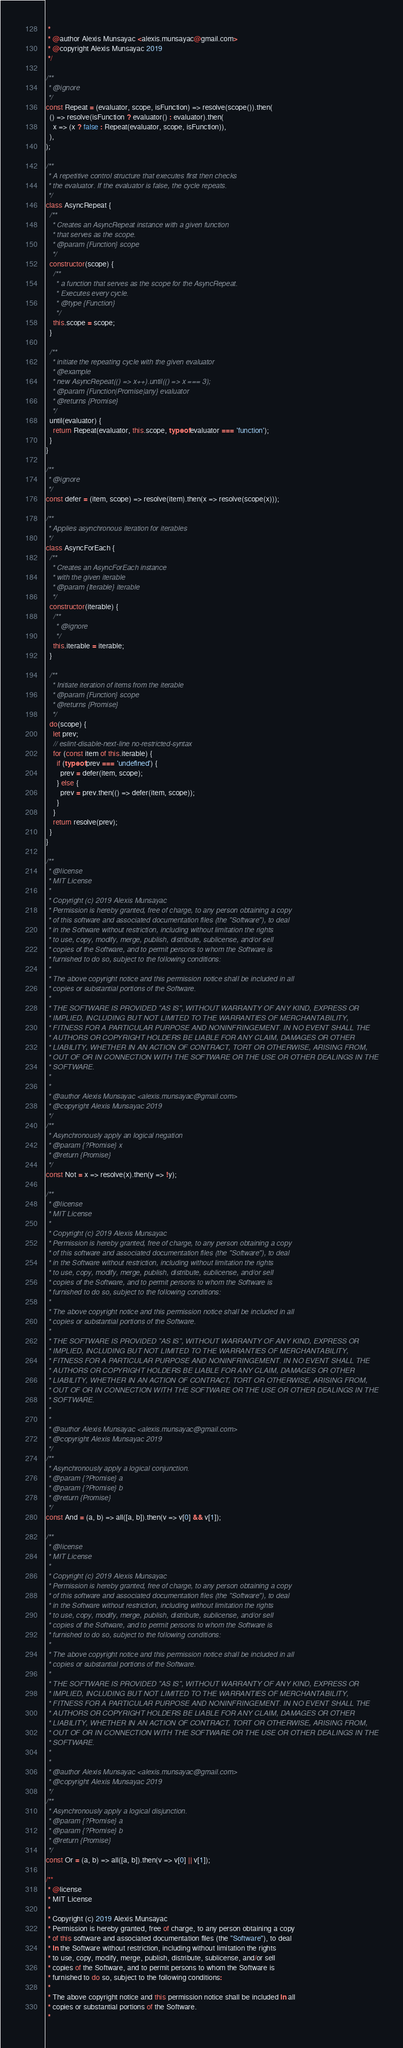<code> <loc_0><loc_0><loc_500><loc_500><_JavaScript_> *
 * @author Alexis Munsayac <alexis.munsayac@gmail.com>
 * @copyright Alexis Munsayac 2019
 */

/**
 * @ignore
 */
const Repeat = (evaluator, scope, isFunction) => resolve(scope()).then(
  () => resolve(isFunction ? evaluator() : evaluator).then(
    x => (x ? false : Repeat(evaluator, scope, isFunction)),
  ),
);

/**
 * A repetitive control structure that executes first then checks
 * the evaluator. If the evaluator is false, the cycle repeats.
 */
class AsyncRepeat {
  /**
   * Creates an AsyncRepeat instance with a given function
   * that serves as the scope.
   * @param {Function} scope
   */
  constructor(scope) {
    /**
     * a function that serves as the scope for the AsyncRepeat.
     * Executes every cycle.
     * @type {Function}
     */
    this.scope = scope;
  }

  /**
   * initiate the repeating cycle with the given evaluator
   * @example
   * new AsyncRepeat(() => x++).until(() => x === 3);
   * @param {Function|Promise|any} evaluator
   * @returns {Promise}
   */
  until(evaluator) {
    return Repeat(evaluator, this.scope, typeof evaluator === 'function');
  }
}

/**
 * @ignore
 */
const defer = (item, scope) => resolve(item).then(x => resolve(scope(x)));

/**
 * Applies asynchronous iteration for iterables
 */
class AsyncForEach {
  /**
   * Creates an AsyncForEach instance
   * with the given iterable
   * @param {Iterable} iterable
   */
  constructor(iterable) {
    /**
     * @ignore
     */
    this.iterable = iterable;
  }

  /**
   * Initiate iteration of items from the iterable
   * @param {Function} scope
   * @returns {Promise}
   */
  do(scope) {
    let prev;
    // eslint-disable-next-line no-restricted-syntax
    for (const item of this.iterable) {
      if (typeof prev === 'undefined') {
        prev = defer(item, scope);
      } else {
        prev = prev.then(() => defer(item, scope));
      }
    }
    return resolve(prev);
  }
}

/**
 * @license
 * MIT License
 *
 * Copyright (c) 2019 Alexis Munsayac
 * Permission is hereby granted, free of charge, to any person obtaining a copy
 * of this software and associated documentation files (the "Software"), to deal
 * in the Software without restriction, including without limitation the rights
 * to use, copy, modify, merge, publish, distribute, sublicense, and/or sell
 * copies of the Software, and to permit persons to whom the Software is
 * furnished to do so, subject to the following conditions:
 *
 * The above copyright notice and this permission notice shall be included in all
 * copies or substantial portions of the Software.
 *
 * THE SOFTWARE IS PROVIDED "AS IS", WITHOUT WARRANTY OF ANY KIND, EXPRESS OR
 * IMPLIED, INCLUDING BUT NOT LIMITED TO THE WARRANTIES OF MERCHANTABILITY,
 * FITNESS FOR A PARTICULAR PURPOSE AND NONINFRINGEMENT. IN NO EVENT SHALL THE
 * AUTHORS OR COPYRIGHT HOLDERS BE LIABLE FOR ANY CLAIM, DAMAGES OR OTHER
 * LIABILITY, WHETHER IN AN ACTION OF CONTRACT, TORT OR OTHERWISE, ARISING FROM,
 * OUT OF OR IN CONNECTION WITH THE SOFTWARE OR THE USE OR OTHER DEALINGS IN THE
 * SOFTWARE.
 *
 *
 * @author Alexis Munsayac <alexis.munsayac@gmail.com>
 * @copyright Alexis Munsayac 2019
 */
/**
 * Asynchronously apply an logical negation
 * @param {?Promise} x
 * @return {Promise}
 */
const Not = x => resolve(x).then(y => !y);

/**
 * @license
 * MIT License
 *
 * Copyright (c) 2019 Alexis Munsayac
 * Permission is hereby granted, free of charge, to any person obtaining a copy
 * of this software and associated documentation files (the "Software"), to deal
 * in the Software without restriction, including without limitation the rights
 * to use, copy, modify, merge, publish, distribute, sublicense, and/or sell
 * copies of the Software, and to permit persons to whom the Software is
 * furnished to do so, subject to the following conditions:
 *
 * The above copyright notice and this permission notice shall be included in all
 * copies or substantial portions of the Software.
 *
 * THE SOFTWARE IS PROVIDED "AS IS", WITHOUT WARRANTY OF ANY KIND, EXPRESS OR
 * IMPLIED, INCLUDING BUT NOT LIMITED TO THE WARRANTIES OF MERCHANTABILITY,
 * FITNESS FOR A PARTICULAR PURPOSE AND NONINFRINGEMENT. IN NO EVENT SHALL THE
 * AUTHORS OR COPYRIGHT HOLDERS BE LIABLE FOR ANY CLAIM, DAMAGES OR OTHER
 * LIABILITY, WHETHER IN AN ACTION OF CONTRACT, TORT OR OTHERWISE, ARISING FROM,
 * OUT OF OR IN CONNECTION WITH THE SOFTWARE OR THE USE OR OTHER DEALINGS IN THE
 * SOFTWARE.
 *
 *
 * @author Alexis Munsayac <alexis.munsayac@gmail.com>
 * @copyright Alexis Munsayac 2019
 */
/**
 * Asynchronously apply a logical conjunction.
 * @param {?Promise} a
 * @param {?Promise} b
 * @return {Promise}
 */
const And = (a, b) => all([a, b]).then(v => v[0] && v[1]);

/**
 * @license
 * MIT License
 *
 * Copyright (c) 2019 Alexis Munsayac
 * Permission is hereby granted, free of charge, to any person obtaining a copy
 * of this software and associated documentation files (the "Software"), to deal
 * in the Software without restriction, including without limitation the rights
 * to use, copy, modify, merge, publish, distribute, sublicense, and/or sell
 * copies of the Software, and to permit persons to whom the Software is
 * furnished to do so, subject to the following conditions:
 *
 * The above copyright notice and this permission notice shall be included in all
 * copies or substantial portions of the Software.
 *
 * THE SOFTWARE IS PROVIDED "AS IS", WITHOUT WARRANTY OF ANY KIND, EXPRESS OR
 * IMPLIED, INCLUDING BUT NOT LIMITED TO THE WARRANTIES OF MERCHANTABILITY,
 * FITNESS FOR A PARTICULAR PURPOSE AND NONINFRINGEMENT. IN NO EVENT SHALL THE
 * AUTHORS OR COPYRIGHT HOLDERS BE LIABLE FOR ANY CLAIM, DAMAGES OR OTHER
 * LIABILITY, WHETHER IN AN ACTION OF CONTRACT, TORT OR OTHERWISE, ARISING FROM,
 * OUT OF OR IN CONNECTION WITH THE SOFTWARE OR THE USE OR OTHER DEALINGS IN THE
 * SOFTWARE.
 *
 *
 * @author Alexis Munsayac <alexis.munsayac@gmail.com>
 * @copyright Alexis Munsayac 2019
 */
/**
 * Asynchronously apply a logical disjunction.
 * @param {?Promise} a
 * @param {?Promise} b
 * @return {Promise}
 */
const Or = (a, b) => all([a, b]).then(v => v[0] || v[1]);

/**
 * @license
 * MIT License
 *
 * Copyright (c) 2019 Alexis Munsayac
 * Permission is hereby granted, free of charge, to any person obtaining a copy
 * of this software and associated documentation files (the "Software"), to deal
 * in the Software without restriction, including without limitation the rights
 * to use, copy, modify, merge, publish, distribute, sublicense, and/or sell
 * copies of the Software, and to permit persons to whom the Software is
 * furnished to do so, subject to the following conditions:
 *
 * The above copyright notice and this permission notice shall be included in all
 * copies or substantial portions of the Software.
 *</code> 